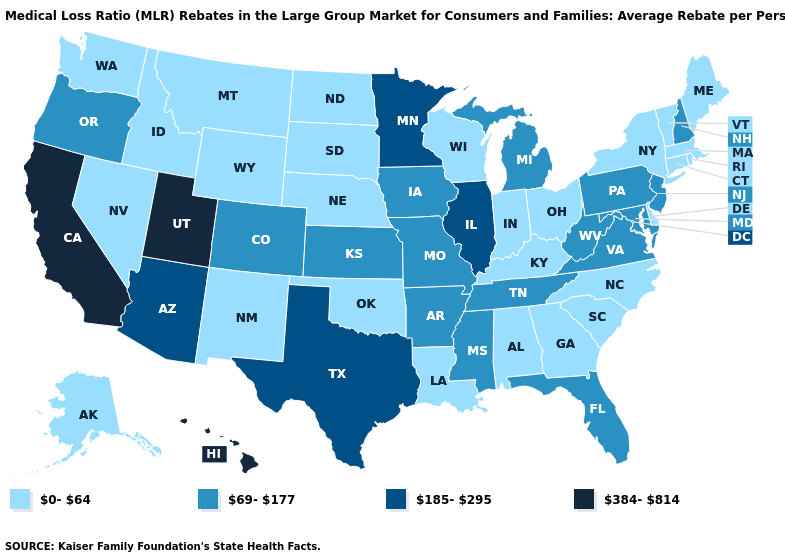Which states hav the highest value in the Northeast?
Be succinct. New Hampshire, New Jersey, Pennsylvania. Name the states that have a value in the range 0-64?
Concise answer only. Alabama, Alaska, Connecticut, Delaware, Georgia, Idaho, Indiana, Kentucky, Louisiana, Maine, Massachusetts, Montana, Nebraska, Nevada, New Mexico, New York, North Carolina, North Dakota, Ohio, Oklahoma, Rhode Island, South Carolina, South Dakota, Vermont, Washington, Wisconsin, Wyoming. Does the map have missing data?
Be succinct. No. Which states have the lowest value in the USA?
Give a very brief answer. Alabama, Alaska, Connecticut, Delaware, Georgia, Idaho, Indiana, Kentucky, Louisiana, Maine, Massachusetts, Montana, Nebraska, Nevada, New Mexico, New York, North Carolina, North Dakota, Ohio, Oklahoma, Rhode Island, South Carolina, South Dakota, Vermont, Washington, Wisconsin, Wyoming. Name the states that have a value in the range 69-177?
Write a very short answer. Arkansas, Colorado, Florida, Iowa, Kansas, Maryland, Michigan, Mississippi, Missouri, New Hampshire, New Jersey, Oregon, Pennsylvania, Tennessee, Virginia, West Virginia. What is the value of Montana?
Write a very short answer. 0-64. Does Missouri have the lowest value in the USA?
Give a very brief answer. No. What is the value of Texas?
Give a very brief answer. 185-295. Among the states that border Iowa , which have the lowest value?
Answer briefly. Nebraska, South Dakota, Wisconsin. Among the states that border New Hampshire , which have the highest value?
Concise answer only. Maine, Massachusetts, Vermont. Name the states that have a value in the range 0-64?
Give a very brief answer. Alabama, Alaska, Connecticut, Delaware, Georgia, Idaho, Indiana, Kentucky, Louisiana, Maine, Massachusetts, Montana, Nebraska, Nevada, New Mexico, New York, North Carolina, North Dakota, Ohio, Oklahoma, Rhode Island, South Carolina, South Dakota, Vermont, Washington, Wisconsin, Wyoming. Which states have the lowest value in the Northeast?
Write a very short answer. Connecticut, Maine, Massachusetts, New York, Rhode Island, Vermont. What is the lowest value in the South?
Answer briefly. 0-64. What is the highest value in the USA?
Write a very short answer. 384-814. 